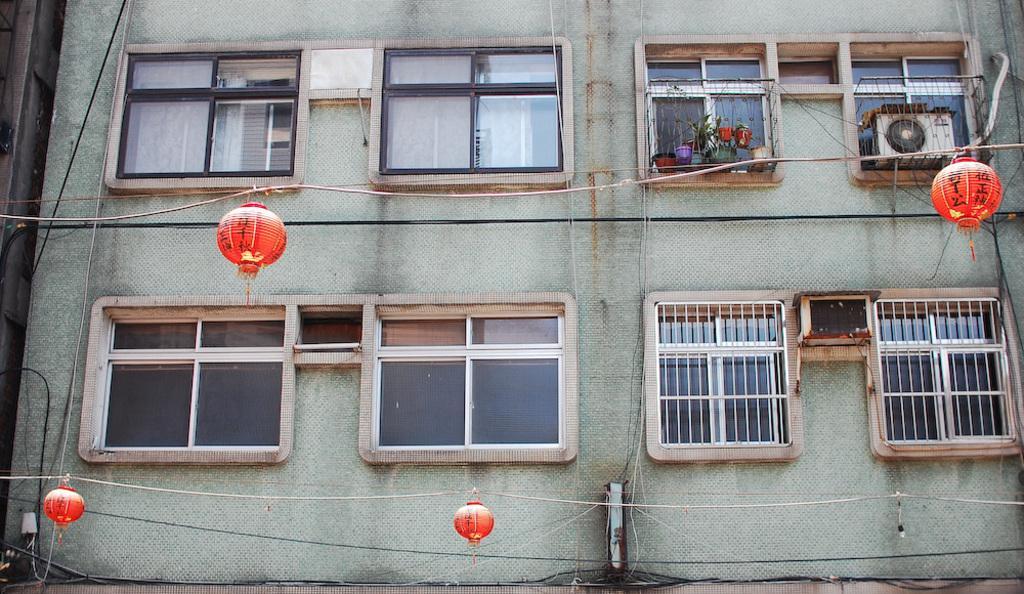Please provide a concise description of this image. In this image there is a building and some glass windows, flower pots, plants, air conditioner and some lights, ropes and wires. On the left side there is another building. 